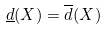Convert formula to latex. <formula><loc_0><loc_0><loc_500><loc_500>\underline { d } ( X ) = \overline { d } ( X )</formula> 